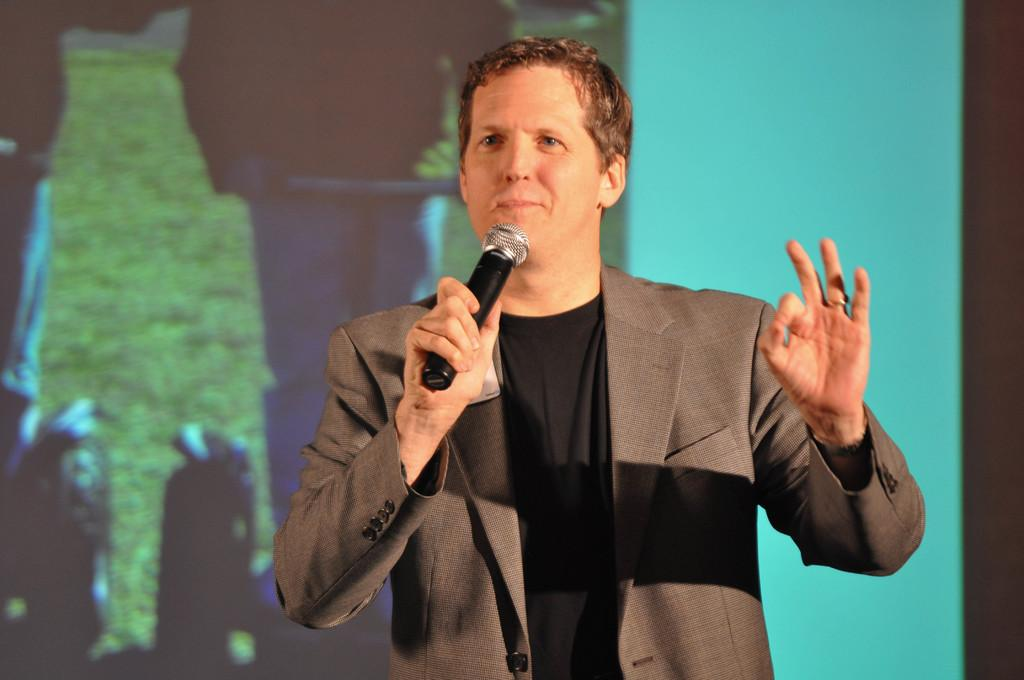Who is the person in the image? There is a man in the image. What is the man doing in the image? The man is standing in the image. What is the man holding in the image? The man is holding a microphone in the image. What is the man wearing in the image? The man is wearing a coat in the image. Can you see a giraffe sitting on a sofa in the image? No, there is no giraffe or sofa present in the image. 